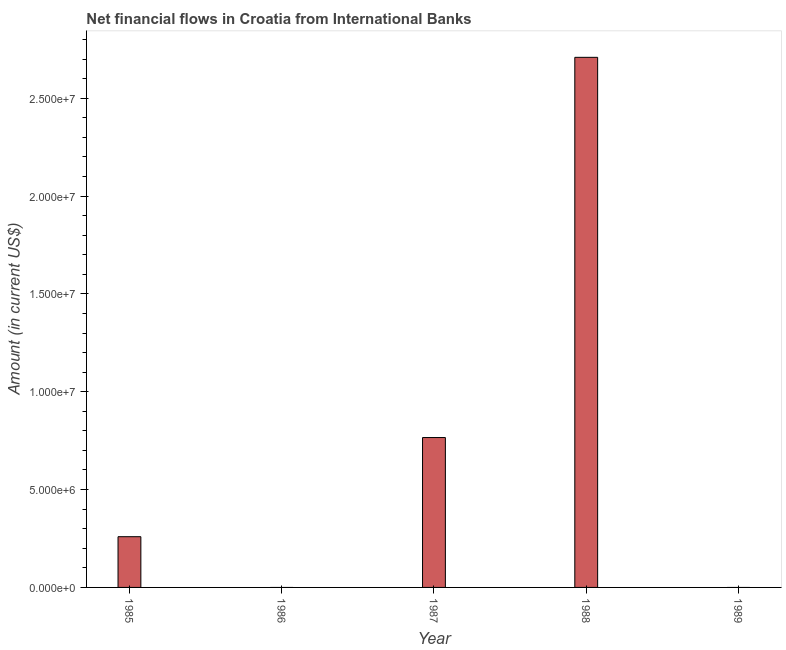Does the graph contain any zero values?
Make the answer very short. Yes. What is the title of the graph?
Provide a short and direct response. Net financial flows in Croatia from International Banks. What is the label or title of the Y-axis?
Give a very brief answer. Amount (in current US$). What is the net financial flows from ibrd in 1988?
Your answer should be very brief. 2.71e+07. Across all years, what is the maximum net financial flows from ibrd?
Keep it short and to the point. 2.71e+07. Across all years, what is the minimum net financial flows from ibrd?
Give a very brief answer. 0. What is the sum of the net financial flows from ibrd?
Your answer should be very brief. 3.73e+07. What is the difference between the net financial flows from ibrd in 1985 and 1987?
Keep it short and to the point. -5.07e+06. What is the average net financial flows from ibrd per year?
Your response must be concise. 7.47e+06. What is the median net financial flows from ibrd?
Give a very brief answer. 2.59e+06. What is the ratio of the net financial flows from ibrd in 1987 to that in 1988?
Keep it short and to the point. 0.28. What is the difference between the highest and the second highest net financial flows from ibrd?
Offer a terse response. 1.94e+07. What is the difference between the highest and the lowest net financial flows from ibrd?
Provide a succinct answer. 2.71e+07. How many bars are there?
Your answer should be very brief. 3. How many years are there in the graph?
Ensure brevity in your answer.  5. What is the difference between two consecutive major ticks on the Y-axis?
Your response must be concise. 5.00e+06. Are the values on the major ticks of Y-axis written in scientific E-notation?
Offer a very short reply. Yes. What is the Amount (in current US$) of 1985?
Keep it short and to the point. 2.59e+06. What is the Amount (in current US$) of 1986?
Your answer should be very brief. 0. What is the Amount (in current US$) in 1987?
Your response must be concise. 7.66e+06. What is the Amount (in current US$) in 1988?
Provide a succinct answer. 2.71e+07. What is the difference between the Amount (in current US$) in 1985 and 1987?
Your response must be concise. -5.07e+06. What is the difference between the Amount (in current US$) in 1985 and 1988?
Offer a very short reply. -2.45e+07. What is the difference between the Amount (in current US$) in 1987 and 1988?
Offer a terse response. -1.94e+07. What is the ratio of the Amount (in current US$) in 1985 to that in 1987?
Offer a terse response. 0.34. What is the ratio of the Amount (in current US$) in 1985 to that in 1988?
Offer a very short reply. 0.1. What is the ratio of the Amount (in current US$) in 1987 to that in 1988?
Your response must be concise. 0.28. 